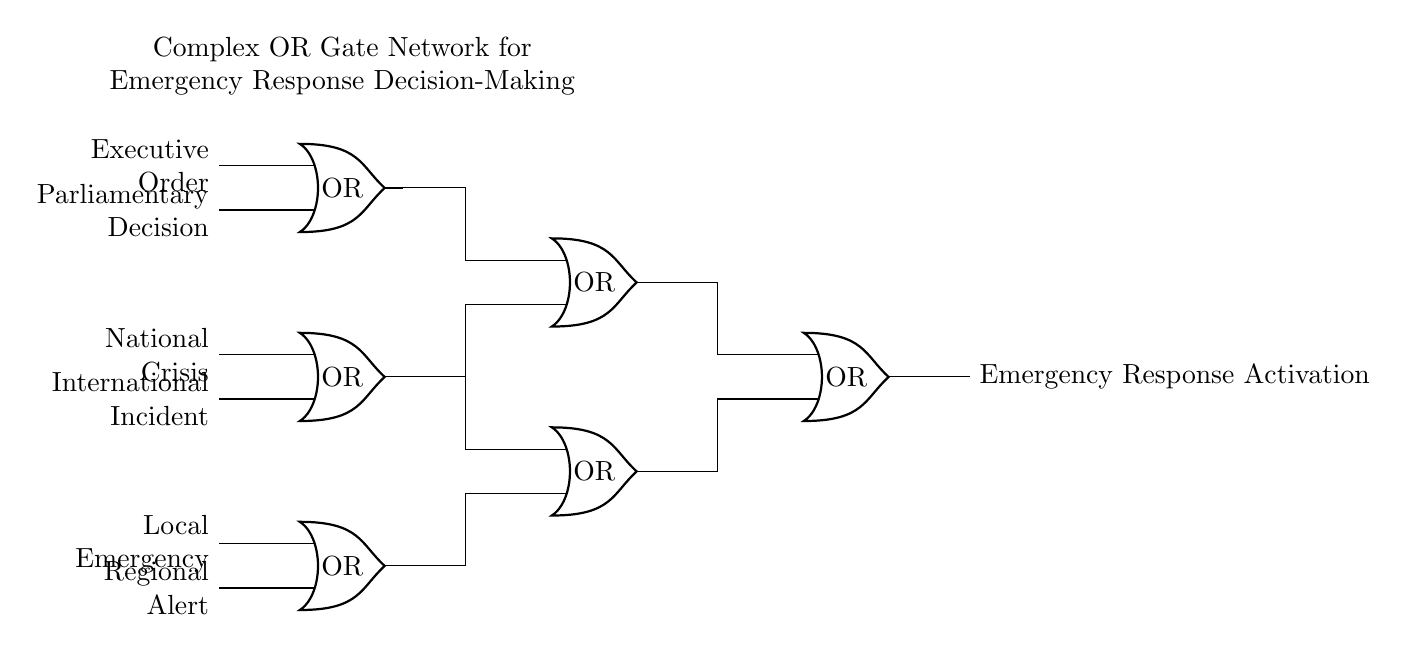What is the output of the circuit? The output of the circuit is "Emergency Response Activation," which is clearly indicated at the right end of the diagram. This label represents the action that results from the inputs processed through the OR gates.
Answer: Emergency Response Activation How many OR gates are present in the circuit? There are six OR gates in the circuit diagram, as depicted by the six separate OR symbols arranged vertically and horizontally. This structural arrangement allows for various input combinations to generate the final output.
Answer: Six What types of inputs feed into the first OR gate? The first OR gate receives two types of inputs: "Local Emergency" and "Regional Alert." These inputs are specifically labeled on the left side of the first OR gate, indicating the sources that influence the initial decision-making process.
Answer: Local Emergency and Regional Alert How many total inputs are connected to the last OR gate? The last OR gate has four total inputs connected to it: two from the previous OR gates (four and five) and two from the outputs of the earlier OR gates (one and two). Evaluating the connections allows us to identify all contributing inputs.
Answer: Four Which OR gate receives inputs from both the national crisis and the international incident? The second OR gate receives inputs from both "National Crisis" and "International Incident." The labels next to the second OR gate confirm that these two specific inputs are utilized in the decision-making process directed by this gate.
Answer: Second OR gate What determines the activation of the emergency response? The activation of the emergency response is determined by the combination of inputs through the OR gates. Each OR gate outputs based on the logical OR function, meaning if any of the inputs are active, the output will signal the emergency response activation.
Answer: Combination of inputs 